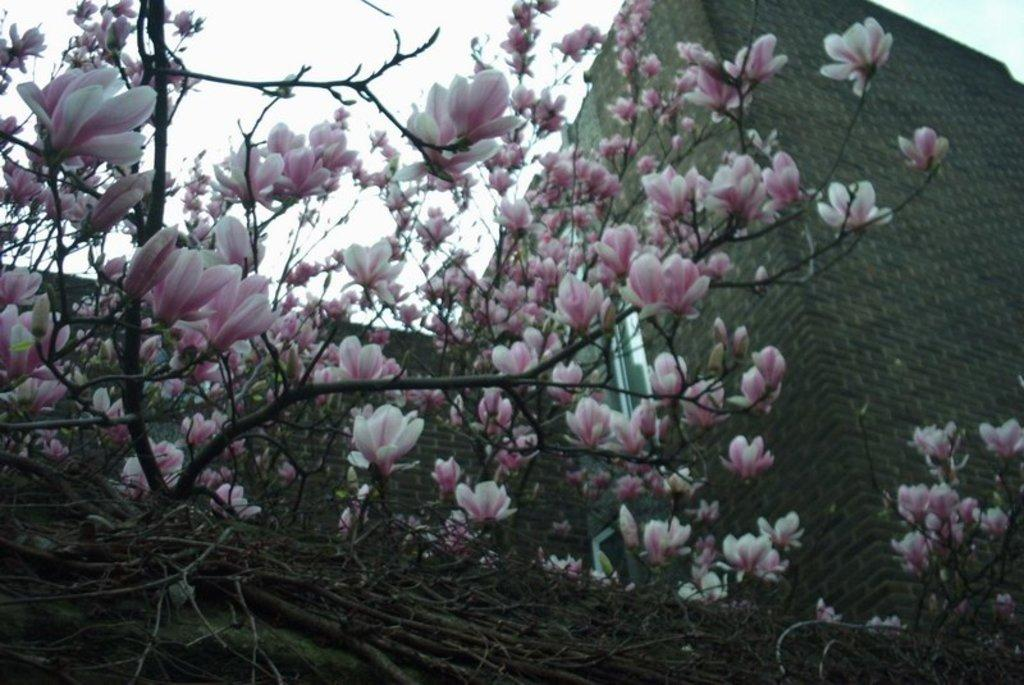What type of vegetation can be seen on the tree in the image? There are flowers on a tree in the image. What can be seen in the distance behind the tree? There is a building in the background of the image. What advice is given on the calendar in the image? There is no calendar present in the image, so no advice can be given. 